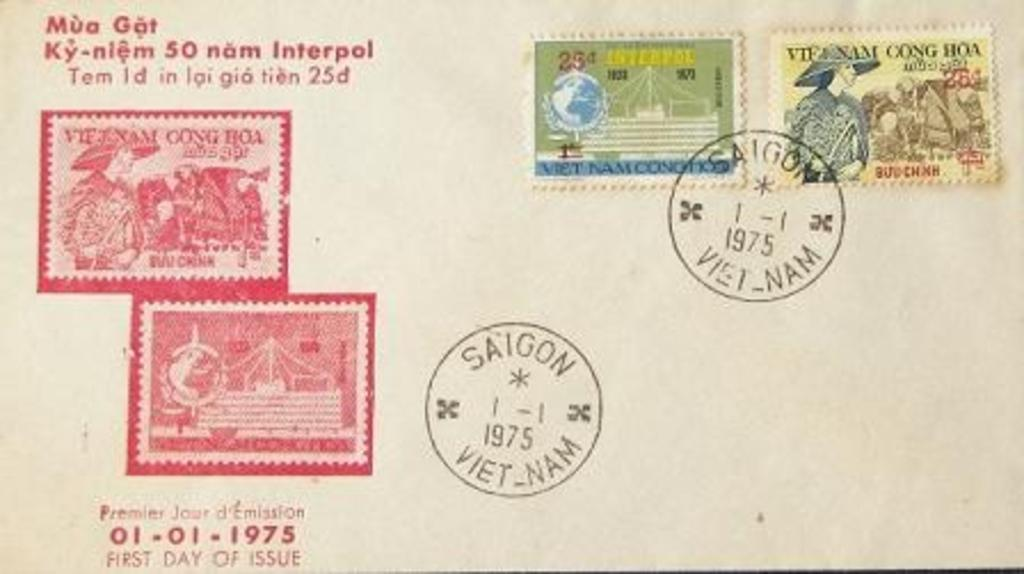Provide a one-sentence caption for the provided image. The back of a post card stamped Saigon 1975 when stamps where 25 cents. 